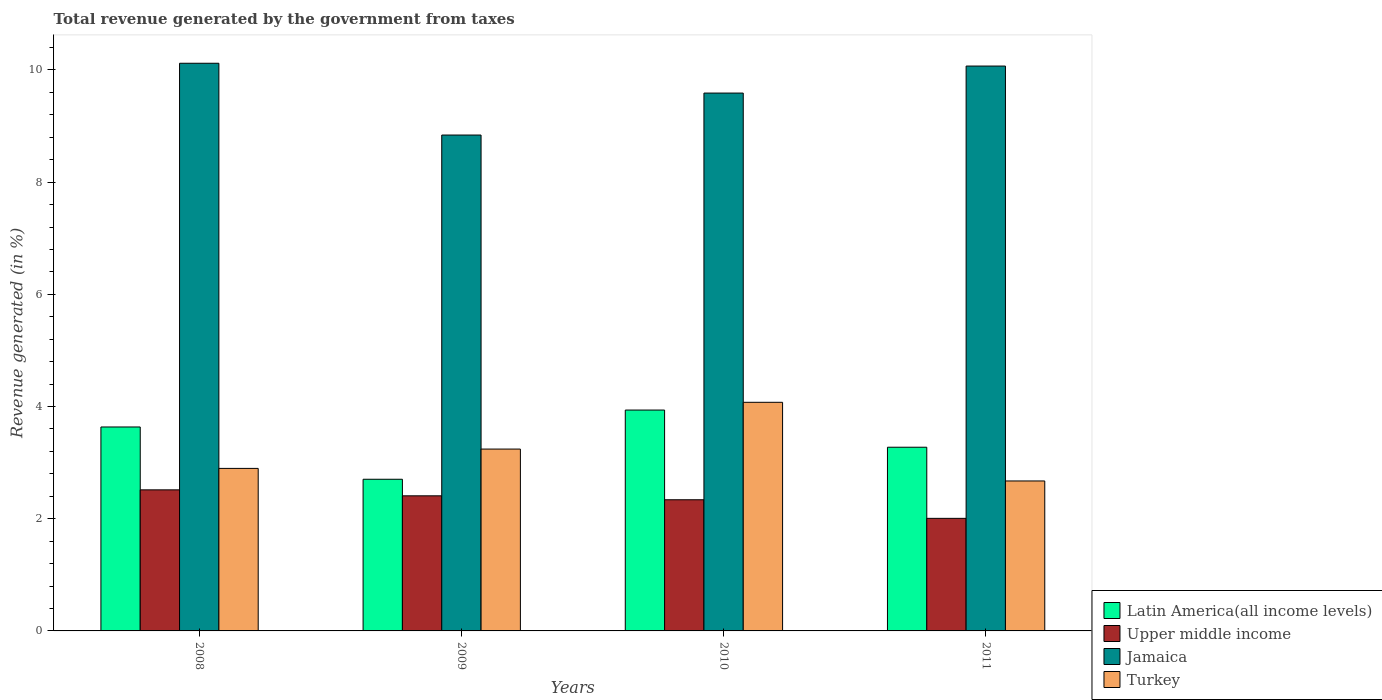How many different coloured bars are there?
Your response must be concise. 4. Are the number of bars on each tick of the X-axis equal?
Your answer should be compact. Yes. How many bars are there on the 2nd tick from the right?
Your answer should be compact. 4. What is the label of the 2nd group of bars from the left?
Offer a very short reply. 2009. In how many cases, is the number of bars for a given year not equal to the number of legend labels?
Make the answer very short. 0. What is the total revenue generated in Turkey in 2010?
Provide a succinct answer. 4.08. Across all years, what is the maximum total revenue generated in Turkey?
Ensure brevity in your answer.  4.08. Across all years, what is the minimum total revenue generated in Upper middle income?
Your answer should be very brief. 2.01. In which year was the total revenue generated in Upper middle income maximum?
Make the answer very short. 2008. In which year was the total revenue generated in Upper middle income minimum?
Your answer should be very brief. 2011. What is the total total revenue generated in Latin America(all income levels) in the graph?
Ensure brevity in your answer.  13.55. What is the difference between the total revenue generated in Jamaica in 2009 and that in 2010?
Give a very brief answer. -0.75. What is the difference between the total revenue generated in Turkey in 2011 and the total revenue generated in Latin America(all income levels) in 2010?
Offer a terse response. -1.26. What is the average total revenue generated in Upper middle income per year?
Provide a succinct answer. 2.32. In the year 2010, what is the difference between the total revenue generated in Jamaica and total revenue generated in Latin America(all income levels)?
Give a very brief answer. 5.65. In how many years, is the total revenue generated in Latin America(all income levels) greater than 2 %?
Your answer should be compact. 4. What is the ratio of the total revenue generated in Upper middle income in 2008 to that in 2010?
Your answer should be very brief. 1.08. Is the total revenue generated in Jamaica in 2008 less than that in 2009?
Your response must be concise. No. Is the difference between the total revenue generated in Jamaica in 2009 and 2010 greater than the difference between the total revenue generated in Latin America(all income levels) in 2009 and 2010?
Your answer should be compact. Yes. What is the difference between the highest and the second highest total revenue generated in Latin America(all income levels)?
Keep it short and to the point. 0.3. What is the difference between the highest and the lowest total revenue generated in Jamaica?
Your answer should be very brief. 1.28. In how many years, is the total revenue generated in Upper middle income greater than the average total revenue generated in Upper middle income taken over all years?
Your answer should be compact. 3. Is it the case that in every year, the sum of the total revenue generated in Upper middle income and total revenue generated in Latin America(all income levels) is greater than the sum of total revenue generated in Turkey and total revenue generated in Jamaica?
Provide a succinct answer. No. What does the 2nd bar from the left in 2011 represents?
Ensure brevity in your answer.  Upper middle income. What does the 1st bar from the right in 2008 represents?
Your answer should be compact. Turkey. How many bars are there?
Offer a very short reply. 16. What is the difference between two consecutive major ticks on the Y-axis?
Your response must be concise. 2. Are the values on the major ticks of Y-axis written in scientific E-notation?
Give a very brief answer. No. Does the graph contain any zero values?
Ensure brevity in your answer.  No. Does the graph contain grids?
Your answer should be very brief. No. How many legend labels are there?
Make the answer very short. 4. What is the title of the graph?
Keep it short and to the point. Total revenue generated by the government from taxes. What is the label or title of the X-axis?
Offer a terse response. Years. What is the label or title of the Y-axis?
Your answer should be very brief. Revenue generated (in %). What is the Revenue generated (in %) in Latin America(all income levels) in 2008?
Provide a short and direct response. 3.64. What is the Revenue generated (in %) of Upper middle income in 2008?
Offer a terse response. 2.51. What is the Revenue generated (in %) in Jamaica in 2008?
Give a very brief answer. 10.12. What is the Revenue generated (in %) in Turkey in 2008?
Keep it short and to the point. 2.9. What is the Revenue generated (in %) of Latin America(all income levels) in 2009?
Your answer should be compact. 2.7. What is the Revenue generated (in %) in Upper middle income in 2009?
Make the answer very short. 2.41. What is the Revenue generated (in %) of Jamaica in 2009?
Make the answer very short. 8.84. What is the Revenue generated (in %) in Turkey in 2009?
Give a very brief answer. 3.24. What is the Revenue generated (in %) of Latin America(all income levels) in 2010?
Make the answer very short. 3.94. What is the Revenue generated (in %) in Upper middle income in 2010?
Your answer should be very brief. 2.34. What is the Revenue generated (in %) in Jamaica in 2010?
Your answer should be very brief. 9.59. What is the Revenue generated (in %) of Turkey in 2010?
Ensure brevity in your answer.  4.08. What is the Revenue generated (in %) of Latin America(all income levels) in 2011?
Your answer should be very brief. 3.27. What is the Revenue generated (in %) of Upper middle income in 2011?
Make the answer very short. 2.01. What is the Revenue generated (in %) of Jamaica in 2011?
Your answer should be very brief. 10.07. What is the Revenue generated (in %) of Turkey in 2011?
Give a very brief answer. 2.67. Across all years, what is the maximum Revenue generated (in %) in Latin America(all income levels)?
Your response must be concise. 3.94. Across all years, what is the maximum Revenue generated (in %) of Upper middle income?
Provide a short and direct response. 2.51. Across all years, what is the maximum Revenue generated (in %) of Jamaica?
Offer a very short reply. 10.12. Across all years, what is the maximum Revenue generated (in %) of Turkey?
Your answer should be compact. 4.08. Across all years, what is the minimum Revenue generated (in %) of Latin America(all income levels)?
Offer a terse response. 2.7. Across all years, what is the minimum Revenue generated (in %) in Upper middle income?
Your answer should be very brief. 2.01. Across all years, what is the minimum Revenue generated (in %) in Jamaica?
Give a very brief answer. 8.84. Across all years, what is the minimum Revenue generated (in %) in Turkey?
Your answer should be very brief. 2.67. What is the total Revenue generated (in %) in Latin America(all income levels) in the graph?
Offer a very short reply. 13.55. What is the total Revenue generated (in %) of Upper middle income in the graph?
Your response must be concise. 9.27. What is the total Revenue generated (in %) in Jamaica in the graph?
Your answer should be compact. 38.62. What is the total Revenue generated (in %) of Turkey in the graph?
Offer a terse response. 12.89. What is the difference between the Revenue generated (in %) of Latin America(all income levels) in 2008 and that in 2009?
Offer a very short reply. 0.93. What is the difference between the Revenue generated (in %) in Upper middle income in 2008 and that in 2009?
Your answer should be compact. 0.11. What is the difference between the Revenue generated (in %) in Jamaica in 2008 and that in 2009?
Give a very brief answer. 1.28. What is the difference between the Revenue generated (in %) in Turkey in 2008 and that in 2009?
Your response must be concise. -0.34. What is the difference between the Revenue generated (in %) in Latin America(all income levels) in 2008 and that in 2010?
Give a very brief answer. -0.3. What is the difference between the Revenue generated (in %) in Upper middle income in 2008 and that in 2010?
Provide a short and direct response. 0.18. What is the difference between the Revenue generated (in %) in Jamaica in 2008 and that in 2010?
Your answer should be compact. 0.53. What is the difference between the Revenue generated (in %) of Turkey in 2008 and that in 2010?
Your answer should be compact. -1.18. What is the difference between the Revenue generated (in %) in Latin America(all income levels) in 2008 and that in 2011?
Provide a short and direct response. 0.36. What is the difference between the Revenue generated (in %) in Upper middle income in 2008 and that in 2011?
Your response must be concise. 0.51. What is the difference between the Revenue generated (in %) of Jamaica in 2008 and that in 2011?
Make the answer very short. 0.05. What is the difference between the Revenue generated (in %) in Turkey in 2008 and that in 2011?
Give a very brief answer. 0.22. What is the difference between the Revenue generated (in %) in Latin America(all income levels) in 2009 and that in 2010?
Offer a very short reply. -1.23. What is the difference between the Revenue generated (in %) of Upper middle income in 2009 and that in 2010?
Your response must be concise. 0.07. What is the difference between the Revenue generated (in %) in Jamaica in 2009 and that in 2010?
Your answer should be very brief. -0.75. What is the difference between the Revenue generated (in %) of Turkey in 2009 and that in 2010?
Give a very brief answer. -0.83. What is the difference between the Revenue generated (in %) of Latin America(all income levels) in 2009 and that in 2011?
Your answer should be very brief. -0.57. What is the difference between the Revenue generated (in %) of Upper middle income in 2009 and that in 2011?
Keep it short and to the point. 0.4. What is the difference between the Revenue generated (in %) of Jamaica in 2009 and that in 2011?
Provide a short and direct response. -1.23. What is the difference between the Revenue generated (in %) of Turkey in 2009 and that in 2011?
Provide a succinct answer. 0.57. What is the difference between the Revenue generated (in %) in Latin America(all income levels) in 2010 and that in 2011?
Provide a short and direct response. 0.66. What is the difference between the Revenue generated (in %) of Upper middle income in 2010 and that in 2011?
Give a very brief answer. 0.33. What is the difference between the Revenue generated (in %) in Jamaica in 2010 and that in 2011?
Your answer should be very brief. -0.48. What is the difference between the Revenue generated (in %) of Turkey in 2010 and that in 2011?
Your answer should be very brief. 1.4. What is the difference between the Revenue generated (in %) in Latin America(all income levels) in 2008 and the Revenue generated (in %) in Upper middle income in 2009?
Keep it short and to the point. 1.23. What is the difference between the Revenue generated (in %) in Latin America(all income levels) in 2008 and the Revenue generated (in %) in Jamaica in 2009?
Provide a succinct answer. -5.2. What is the difference between the Revenue generated (in %) in Latin America(all income levels) in 2008 and the Revenue generated (in %) in Turkey in 2009?
Provide a short and direct response. 0.39. What is the difference between the Revenue generated (in %) of Upper middle income in 2008 and the Revenue generated (in %) of Jamaica in 2009?
Provide a short and direct response. -6.33. What is the difference between the Revenue generated (in %) in Upper middle income in 2008 and the Revenue generated (in %) in Turkey in 2009?
Offer a terse response. -0.73. What is the difference between the Revenue generated (in %) of Jamaica in 2008 and the Revenue generated (in %) of Turkey in 2009?
Provide a succinct answer. 6.88. What is the difference between the Revenue generated (in %) of Latin America(all income levels) in 2008 and the Revenue generated (in %) of Upper middle income in 2010?
Give a very brief answer. 1.3. What is the difference between the Revenue generated (in %) of Latin America(all income levels) in 2008 and the Revenue generated (in %) of Jamaica in 2010?
Ensure brevity in your answer.  -5.95. What is the difference between the Revenue generated (in %) in Latin America(all income levels) in 2008 and the Revenue generated (in %) in Turkey in 2010?
Offer a terse response. -0.44. What is the difference between the Revenue generated (in %) of Upper middle income in 2008 and the Revenue generated (in %) of Jamaica in 2010?
Your response must be concise. -7.07. What is the difference between the Revenue generated (in %) of Upper middle income in 2008 and the Revenue generated (in %) of Turkey in 2010?
Provide a short and direct response. -1.56. What is the difference between the Revenue generated (in %) of Jamaica in 2008 and the Revenue generated (in %) of Turkey in 2010?
Provide a succinct answer. 6.04. What is the difference between the Revenue generated (in %) in Latin America(all income levels) in 2008 and the Revenue generated (in %) in Upper middle income in 2011?
Your response must be concise. 1.63. What is the difference between the Revenue generated (in %) in Latin America(all income levels) in 2008 and the Revenue generated (in %) in Jamaica in 2011?
Offer a very short reply. -6.43. What is the difference between the Revenue generated (in %) of Latin America(all income levels) in 2008 and the Revenue generated (in %) of Turkey in 2011?
Your answer should be compact. 0.96. What is the difference between the Revenue generated (in %) in Upper middle income in 2008 and the Revenue generated (in %) in Jamaica in 2011?
Offer a very short reply. -7.55. What is the difference between the Revenue generated (in %) of Upper middle income in 2008 and the Revenue generated (in %) of Turkey in 2011?
Your answer should be very brief. -0.16. What is the difference between the Revenue generated (in %) in Jamaica in 2008 and the Revenue generated (in %) in Turkey in 2011?
Provide a short and direct response. 7.45. What is the difference between the Revenue generated (in %) of Latin America(all income levels) in 2009 and the Revenue generated (in %) of Upper middle income in 2010?
Your answer should be compact. 0.37. What is the difference between the Revenue generated (in %) in Latin America(all income levels) in 2009 and the Revenue generated (in %) in Jamaica in 2010?
Make the answer very short. -6.88. What is the difference between the Revenue generated (in %) of Latin America(all income levels) in 2009 and the Revenue generated (in %) of Turkey in 2010?
Give a very brief answer. -1.37. What is the difference between the Revenue generated (in %) in Upper middle income in 2009 and the Revenue generated (in %) in Jamaica in 2010?
Keep it short and to the point. -7.18. What is the difference between the Revenue generated (in %) in Upper middle income in 2009 and the Revenue generated (in %) in Turkey in 2010?
Your answer should be very brief. -1.67. What is the difference between the Revenue generated (in %) in Jamaica in 2009 and the Revenue generated (in %) in Turkey in 2010?
Your answer should be compact. 4.76. What is the difference between the Revenue generated (in %) in Latin America(all income levels) in 2009 and the Revenue generated (in %) in Upper middle income in 2011?
Offer a very short reply. 0.7. What is the difference between the Revenue generated (in %) of Latin America(all income levels) in 2009 and the Revenue generated (in %) of Jamaica in 2011?
Offer a terse response. -7.37. What is the difference between the Revenue generated (in %) of Latin America(all income levels) in 2009 and the Revenue generated (in %) of Turkey in 2011?
Ensure brevity in your answer.  0.03. What is the difference between the Revenue generated (in %) in Upper middle income in 2009 and the Revenue generated (in %) in Jamaica in 2011?
Make the answer very short. -7.66. What is the difference between the Revenue generated (in %) of Upper middle income in 2009 and the Revenue generated (in %) of Turkey in 2011?
Your answer should be very brief. -0.26. What is the difference between the Revenue generated (in %) of Jamaica in 2009 and the Revenue generated (in %) of Turkey in 2011?
Your response must be concise. 6.17. What is the difference between the Revenue generated (in %) in Latin America(all income levels) in 2010 and the Revenue generated (in %) in Upper middle income in 2011?
Offer a terse response. 1.93. What is the difference between the Revenue generated (in %) in Latin America(all income levels) in 2010 and the Revenue generated (in %) in Jamaica in 2011?
Your answer should be very brief. -6.13. What is the difference between the Revenue generated (in %) of Latin America(all income levels) in 2010 and the Revenue generated (in %) of Turkey in 2011?
Offer a terse response. 1.26. What is the difference between the Revenue generated (in %) of Upper middle income in 2010 and the Revenue generated (in %) of Jamaica in 2011?
Offer a terse response. -7.73. What is the difference between the Revenue generated (in %) of Upper middle income in 2010 and the Revenue generated (in %) of Turkey in 2011?
Provide a succinct answer. -0.34. What is the difference between the Revenue generated (in %) of Jamaica in 2010 and the Revenue generated (in %) of Turkey in 2011?
Your answer should be very brief. 6.91. What is the average Revenue generated (in %) in Latin America(all income levels) per year?
Keep it short and to the point. 3.39. What is the average Revenue generated (in %) of Upper middle income per year?
Make the answer very short. 2.32. What is the average Revenue generated (in %) in Jamaica per year?
Keep it short and to the point. 9.65. What is the average Revenue generated (in %) of Turkey per year?
Keep it short and to the point. 3.22. In the year 2008, what is the difference between the Revenue generated (in %) in Latin America(all income levels) and Revenue generated (in %) in Upper middle income?
Your answer should be very brief. 1.12. In the year 2008, what is the difference between the Revenue generated (in %) of Latin America(all income levels) and Revenue generated (in %) of Jamaica?
Provide a short and direct response. -6.48. In the year 2008, what is the difference between the Revenue generated (in %) in Latin America(all income levels) and Revenue generated (in %) in Turkey?
Provide a short and direct response. 0.74. In the year 2008, what is the difference between the Revenue generated (in %) of Upper middle income and Revenue generated (in %) of Jamaica?
Give a very brief answer. -7.6. In the year 2008, what is the difference between the Revenue generated (in %) of Upper middle income and Revenue generated (in %) of Turkey?
Offer a very short reply. -0.38. In the year 2008, what is the difference between the Revenue generated (in %) in Jamaica and Revenue generated (in %) in Turkey?
Offer a very short reply. 7.22. In the year 2009, what is the difference between the Revenue generated (in %) in Latin America(all income levels) and Revenue generated (in %) in Upper middle income?
Offer a very short reply. 0.3. In the year 2009, what is the difference between the Revenue generated (in %) of Latin America(all income levels) and Revenue generated (in %) of Jamaica?
Provide a succinct answer. -6.14. In the year 2009, what is the difference between the Revenue generated (in %) of Latin America(all income levels) and Revenue generated (in %) of Turkey?
Offer a terse response. -0.54. In the year 2009, what is the difference between the Revenue generated (in %) in Upper middle income and Revenue generated (in %) in Jamaica?
Give a very brief answer. -6.43. In the year 2009, what is the difference between the Revenue generated (in %) in Upper middle income and Revenue generated (in %) in Turkey?
Provide a succinct answer. -0.83. In the year 2009, what is the difference between the Revenue generated (in %) of Jamaica and Revenue generated (in %) of Turkey?
Offer a very short reply. 5.6. In the year 2010, what is the difference between the Revenue generated (in %) in Latin America(all income levels) and Revenue generated (in %) in Upper middle income?
Offer a very short reply. 1.6. In the year 2010, what is the difference between the Revenue generated (in %) in Latin America(all income levels) and Revenue generated (in %) in Jamaica?
Offer a terse response. -5.65. In the year 2010, what is the difference between the Revenue generated (in %) of Latin America(all income levels) and Revenue generated (in %) of Turkey?
Provide a succinct answer. -0.14. In the year 2010, what is the difference between the Revenue generated (in %) in Upper middle income and Revenue generated (in %) in Jamaica?
Offer a very short reply. -7.25. In the year 2010, what is the difference between the Revenue generated (in %) in Upper middle income and Revenue generated (in %) in Turkey?
Offer a terse response. -1.74. In the year 2010, what is the difference between the Revenue generated (in %) in Jamaica and Revenue generated (in %) in Turkey?
Provide a succinct answer. 5.51. In the year 2011, what is the difference between the Revenue generated (in %) in Latin America(all income levels) and Revenue generated (in %) in Upper middle income?
Keep it short and to the point. 1.27. In the year 2011, what is the difference between the Revenue generated (in %) in Latin America(all income levels) and Revenue generated (in %) in Jamaica?
Keep it short and to the point. -6.79. In the year 2011, what is the difference between the Revenue generated (in %) of Latin America(all income levels) and Revenue generated (in %) of Turkey?
Provide a succinct answer. 0.6. In the year 2011, what is the difference between the Revenue generated (in %) in Upper middle income and Revenue generated (in %) in Jamaica?
Make the answer very short. -8.06. In the year 2011, what is the difference between the Revenue generated (in %) in Upper middle income and Revenue generated (in %) in Turkey?
Provide a succinct answer. -0.67. In the year 2011, what is the difference between the Revenue generated (in %) in Jamaica and Revenue generated (in %) in Turkey?
Provide a short and direct response. 7.4. What is the ratio of the Revenue generated (in %) of Latin America(all income levels) in 2008 to that in 2009?
Offer a very short reply. 1.34. What is the ratio of the Revenue generated (in %) of Upper middle income in 2008 to that in 2009?
Your response must be concise. 1.04. What is the ratio of the Revenue generated (in %) in Jamaica in 2008 to that in 2009?
Offer a terse response. 1.14. What is the ratio of the Revenue generated (in %) of Turkey in 2008 to that in 2009?
Make the answer very short. 0.89. What is the ratio of the Revenue generated (in %) of Latin America(all income levels) in 2008 to that in 2010?
Give a very brief answer. 0.92. What is the ratio of the Revenue generated (in %) in Upper middle income in 2008 to that in 2010?
Your answer should be compact. 1.08. What is the ratio of the Revenue generated (in %) of Jamaica in 2008 to that in 2010?
Keep it short and to the point. 1.06. What is the ratio of the Revenue generated (in %) of Turkey in 2008 to that in 2010?
Your response must be concise. 0.71. What is the ratio of the Revenue generated (in %) of Latin America(all income levels) in 2008 to that in 2011?
Your answer should be very brief. 1.11. What is the ratio of the Revenue generated (in %) in Upper middle income in 2008 to that in 2011?
Make the answer very short. 1.25. What is the ratio of the Revenue generated (in %) in Turkey in 2008 to that in 2011?
Give a very brief answer. 1.08. What is the ratio of the Revenue generated (in %) in Latin America(all income levels) in 2009 to that in 2010?
Offer a terse response. 0.69. What is the ratio of the Revenue generated (in %) in Upper middle income in 2009 to that in 2010?
Give a very brief answer. 1.03. What is the ratio of the Revenue generated (in %) of Jamaica in 2009 to that in 2010?
Ensure brevity in your answer.  0.92. What is the ratio of the Revenue generated (in %) in Turkey in 2009 to that in 2010?
Ensure brevity in your answer.  0.8. What is the ratio of the Revenue generated (in %) in Latin America(all income levels) in 2009 to that in 2011?
Offer a terse response. 0.83. What is the ratio of the Revenue generated (in %) of Upper middle income in 2009 to that in 2011?
Ensure brevity in your answer.  1.2. What is the ratio of the Revenue generated (in %) in Jamaica in 2009 to that in 2011?
Give a very brief answer. 0.88. What is the ratio of the Revenue generated (in %) in Turkey in 2009 to that in 2011?
Make the answer very short. 1.21. What is the ratio of the Revenue generated (in %) in Latin America(all income levels) in 2010 to that in 2011?
Offer a very short reply. 1.2. What is the ratio of the Revenue generated (in %) in Upper middle income in 2010 to that in 2011?
Ensure brevity in your answer.  1.17. What is the ratio of the Revenue generated (in %) of Jamaica in 2010 to that in 2011?
Offer a terse response. 0.95. What is the ratio of the Revenue generated (in %) in Turkey in 2010 to that in 2011?
Your answer should be very brief. 1.52. What is the difference between the highest and the second highest Revenue generated (in %) of Latin America(all income levels)?
Provide a succinct answer. 0.3. What is the difference between the highest and the second highest Revenue generated (in %) in Upper middle income?
Your response must be concise. 0.11. What is the difference between the highest and the second highest Revenue generated (in %) in Jamaica?
Make the answer very short. 0.05. What is the difference between the highest and the second highest Revenue generated (in %) of Turkey?
Provide a succinct answer. 0.83. What is the difference between the highest and the lowest Revenue generated (in %) in Latin America(all income levels)?
Your answer should be compact. 1.23. What is the difference between the highest and the lowest Revenue generated (in %) of Upper middle income?
Your answer should be very brief. 0.51. What is the difference between the highest and the lowest Revenue generated (in %) of Jamaica?
Offer a very short reply. 1.28. What is the difference between the highest and the lowest Revenue generated (in %) in Turkey?
Your response must be concise. 1.4. 